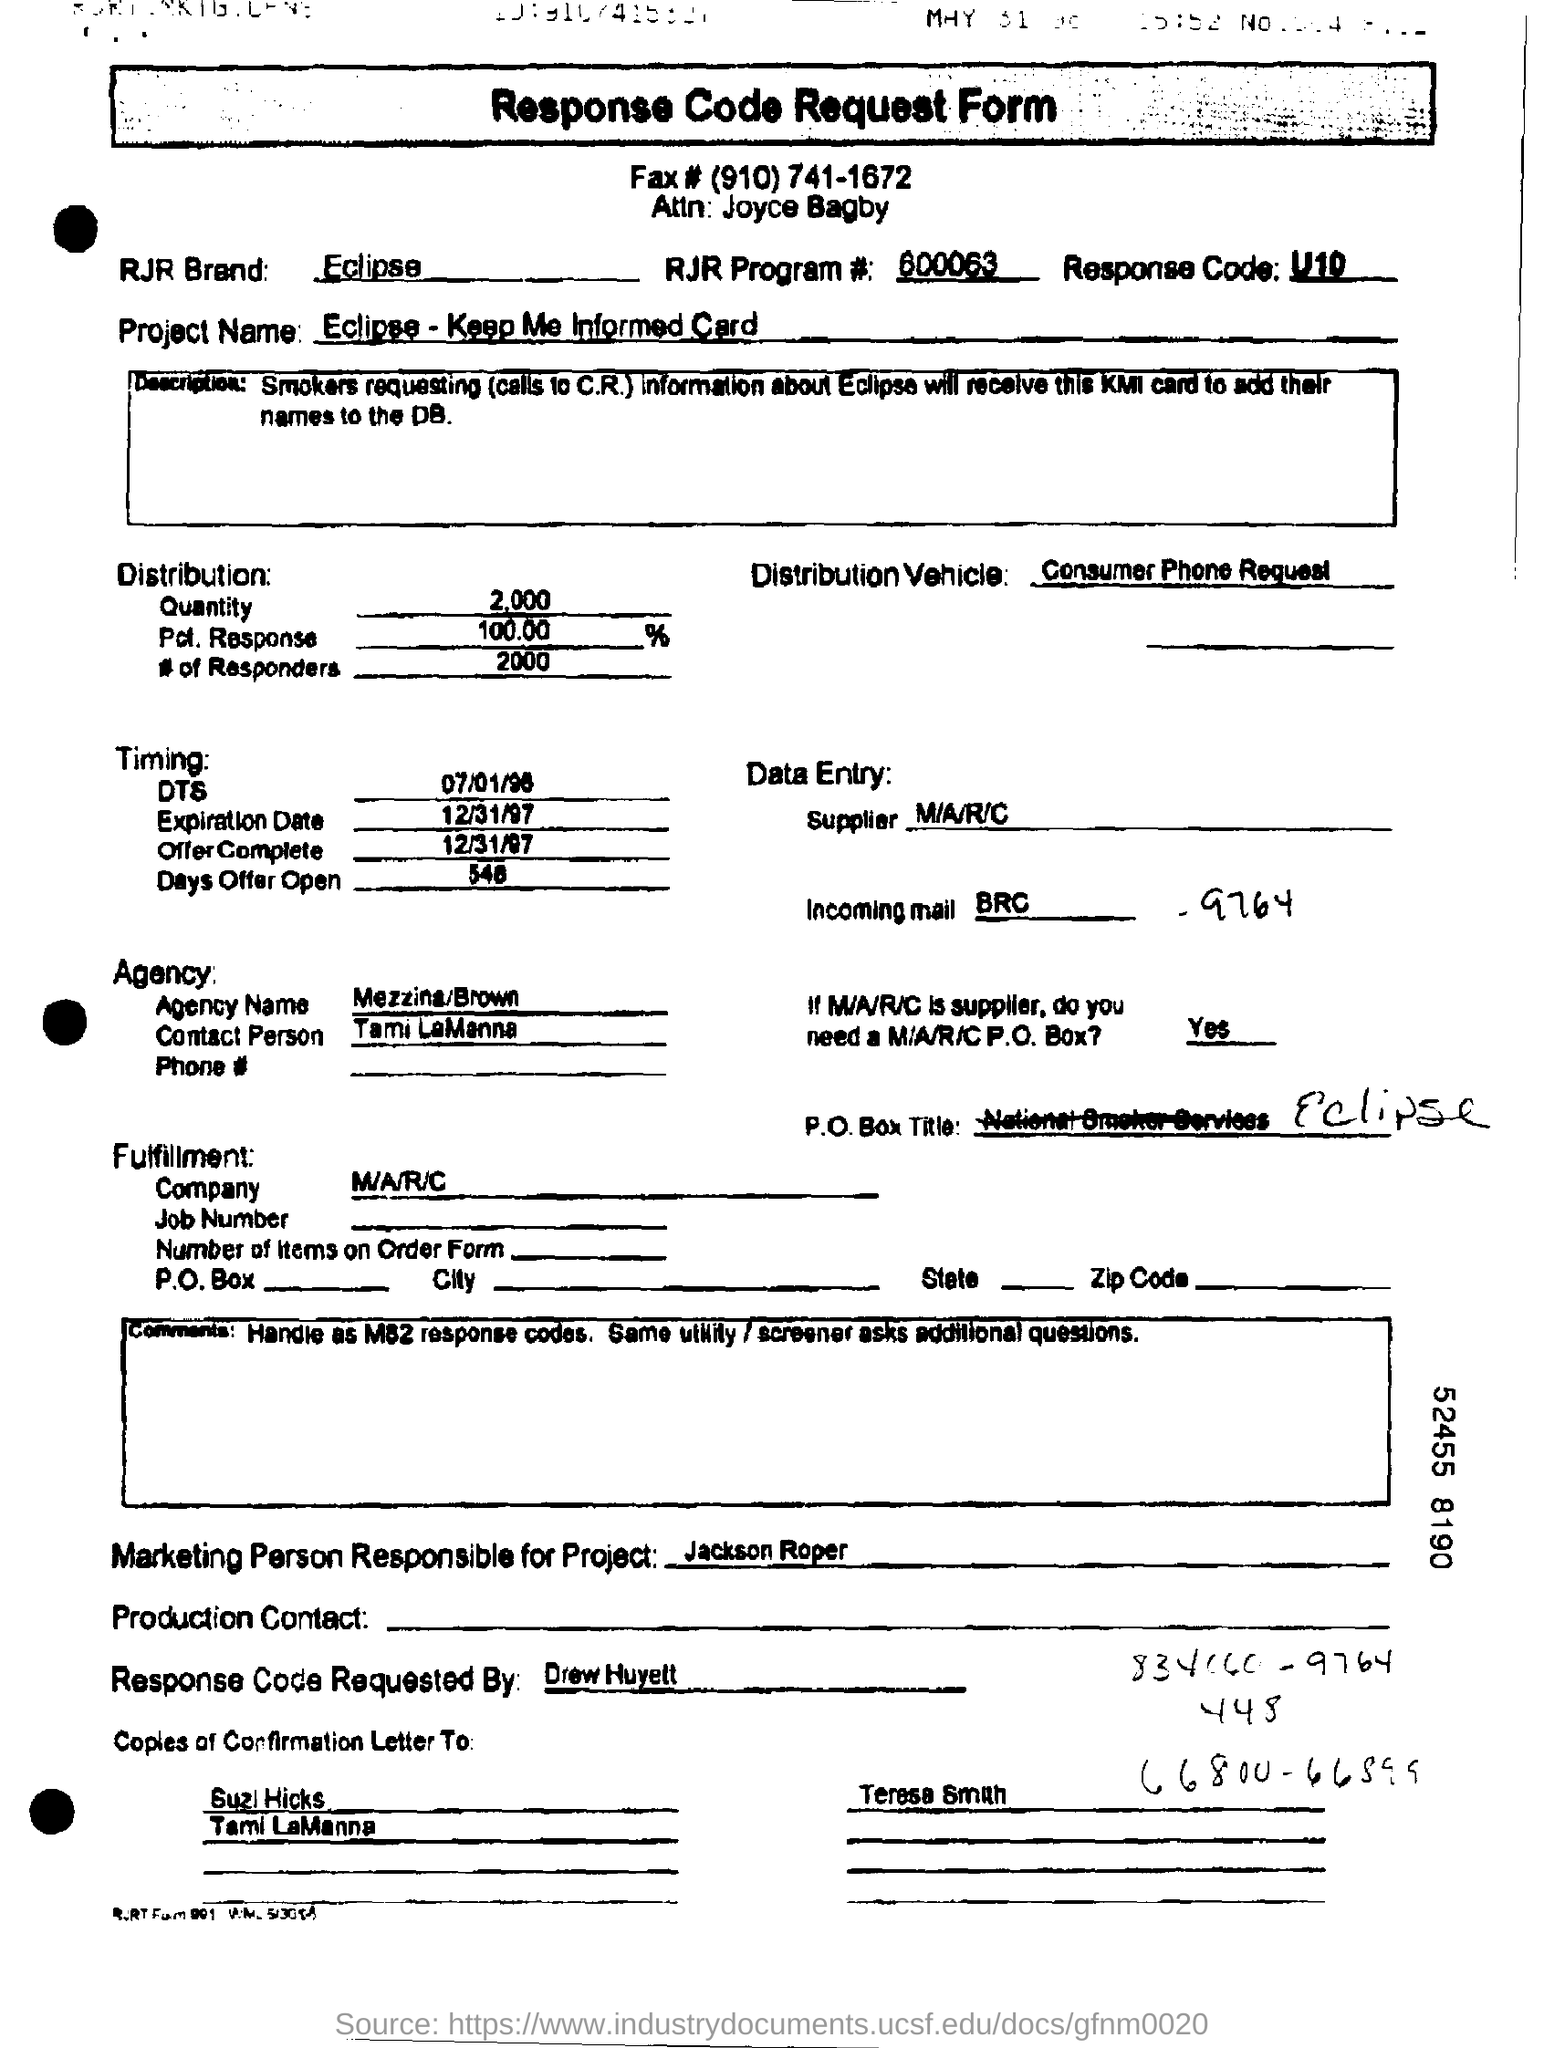What is the Project Name?
Offer a terse response. Eclipse - Keep Me Informed Card. Who is the Marketing Person Responsible for Project?
Your answer should be compact. Jackson Roper. 